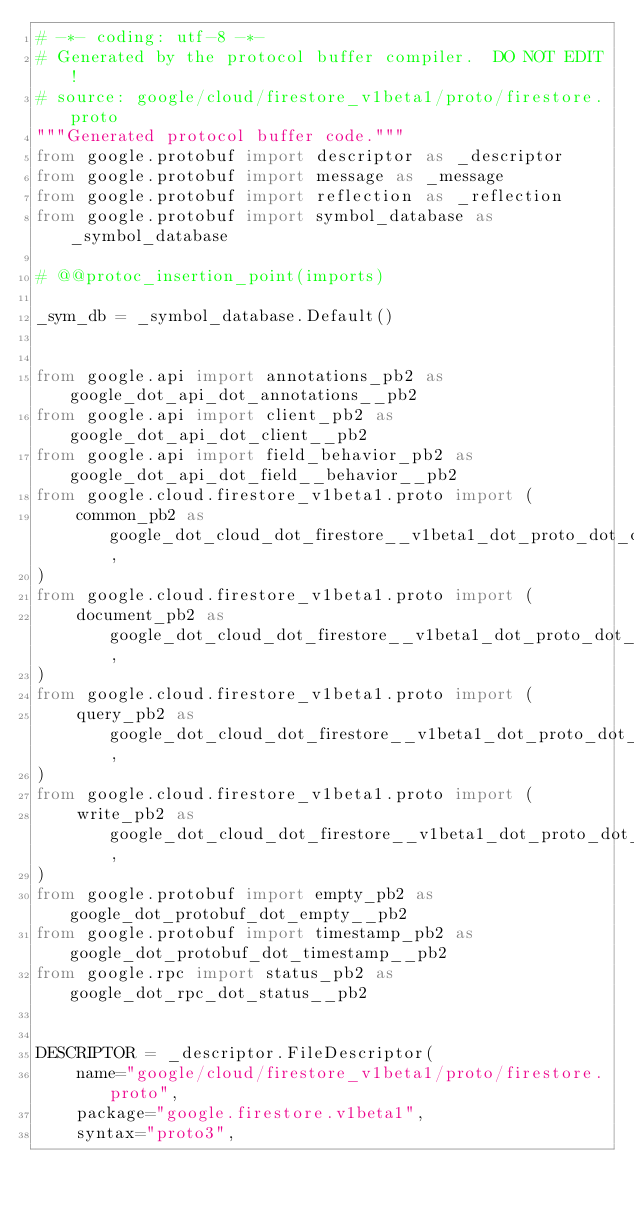<code> <loc_0><loc_0><loc_500><loc_500><_Python_># -*- coding: utf-8 -*-
# Generated by the protocol buffer compiler.  DO NOT EDIT!
# source: google/cloud/firestore_v1beta1/proto/firestore.proto
"""Generated protocol buffer code."""
from google.protobuf import descriptor as _descriptor
from google.protobuf import message as _message
from google.protobuf import reflection as _reflection
from google.protobuf import symbol_database as _symbol_database

# @@protoc_insertion_point(imports)

_sym_db = _symbol_database.Default()


from google.api import annotations_pb2 as google_dot_api_dot_annotations__pb2
from google.api import client_pb2 as google_dot_api_dot_client__pb2
from google.api import field_behavior_pb2 as google_dot_api_dot_field__behavior__pb2
from google.cloud.firestore_v1beta1.proto import (
    common_pb2 as google_dot_cloud_dot_firestore__v1beta1_dot_proto_dot_common__pb2,
)
from google.cloud.firestore_v1beta1.proto import (
    document_pb2 as google_dot_cloud_dot_firestore__v1beta1_dot_proto_dot_document__pb2,
)
from google.cloud.firestore_v1beta1.proto import (
    query_pb2 as google_dot_cloud_dot_firestore__v1beta1_dot_proto_dot_query__pb2,
)
from google.cloud.firestore_v1beta1.proto import (
    write_pb2 as google_dot_cloud_dot_firestore__v1beta1_dot_proto_dot_write__pb2,
)
from google.protobuf import empty_pb2 as google_dot_protobuf_dot_empty__pb2
from google.protobuf import timestamp_pb2 as google_dot_protobuf_dot_timestamp__pb2
from google.rpc import status_pb2 as google_dot_rpc_dot_status__pb2


DESCRIPTOR = _descriptor.FileDescriptor(
    name="google/cloud/firestore_v1beta1/proto/firestore.proto",
    package="google.firestore.v1beta1",
    syntax="proto3",</code> 